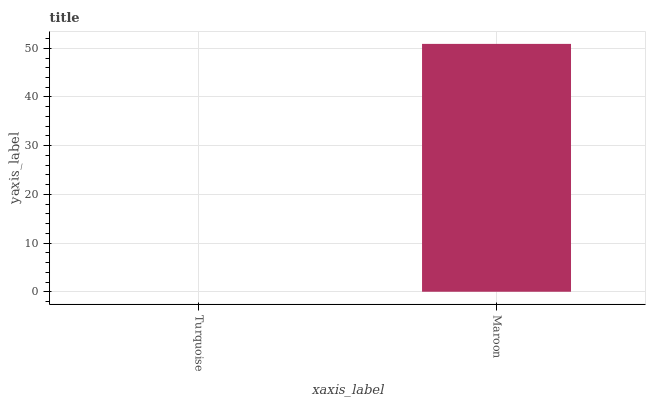Is Turquoise the minimum?
Answer yes or no. Yes. Is Maroon the maximum?
Answer yes or no. Yes. Is Maroon the minimum?
Answer yes or no. No. Is Maroon greater than Turquoise?
Answer yes or no. Yes. Is Turquoise less than Maroon?
Answer yes or no. Yes. Is Turquoise greater than Maroon?
Answer yes or no. No. Is Maroon less than Turquoise?
Answer yes or no. No. Is Maroon the high median?
Answer yes or no. Yes. Is Turquoise the low median?
Answer yes or no. Yes. Is Turquoise the high median?
Answer yes or no. No. Is Maroon the low median?
Answer yes or no. No. 